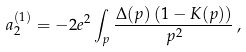Convert formula to latex. <formula><loc_0><loc_0><loc_500><loc_500>a _ { 2 } ^ { ( 1 ) } = - 2 e ^ { 2 } \int _ { p } \frac { \Delta ( p ) \left ( 1 - K ( p ) \right ) } { p ^ { 2 } } \, ,</formula> 